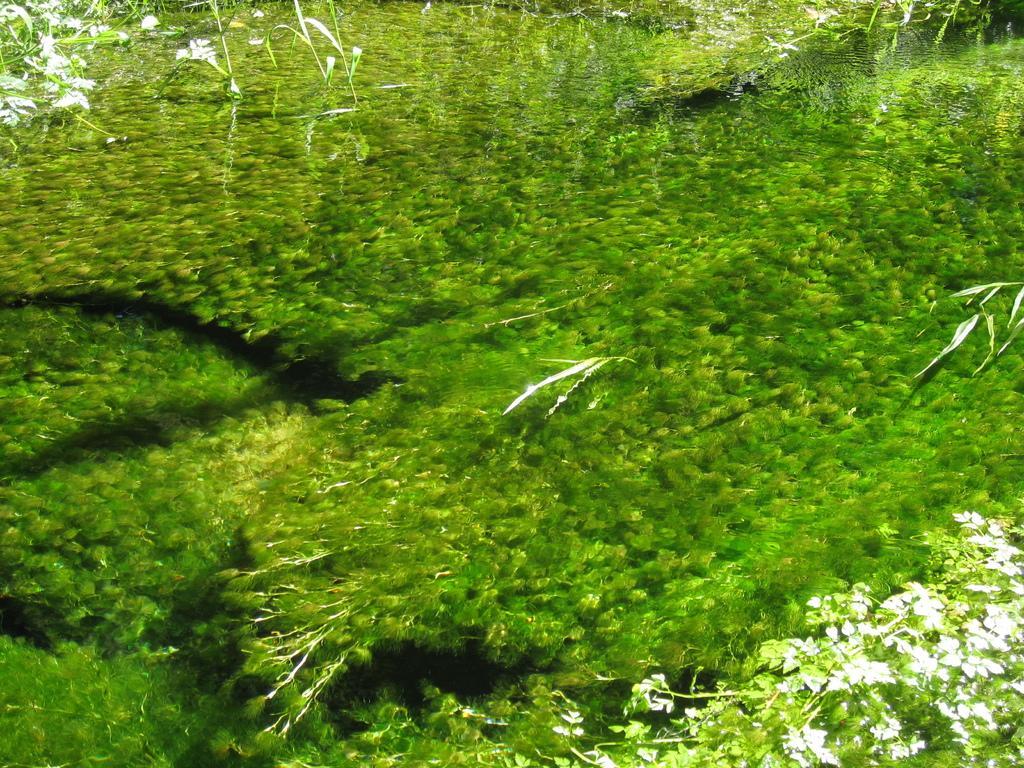Could you give a brief overview of what you see in this image? The picture consists of a water bottle, in the water there is greenery might be plants. On the right there are plants above the water. On the left there are plants above the water. 